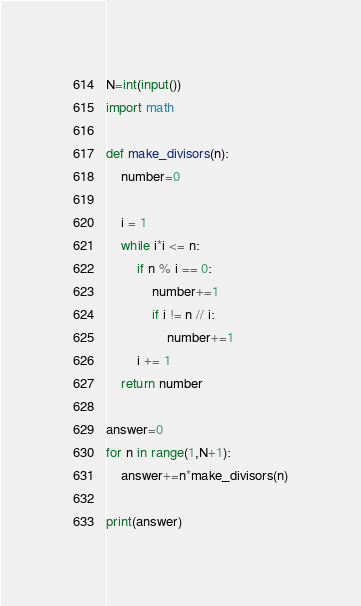<code> <loc_0><loc_0><loc_500><loc_500><_Python_>N=int(input())
import math

def make_divisors(n):
    number=0

    i = 1
    while i*i <= n:
        if n % i == 0:
            number+=1
            if i != n // i:
                number+=1
        i += 1
    return number

answer=0
for n in range(1,N+1):
    answer+=n*make_divisors(n)

print(answer)
</code> 